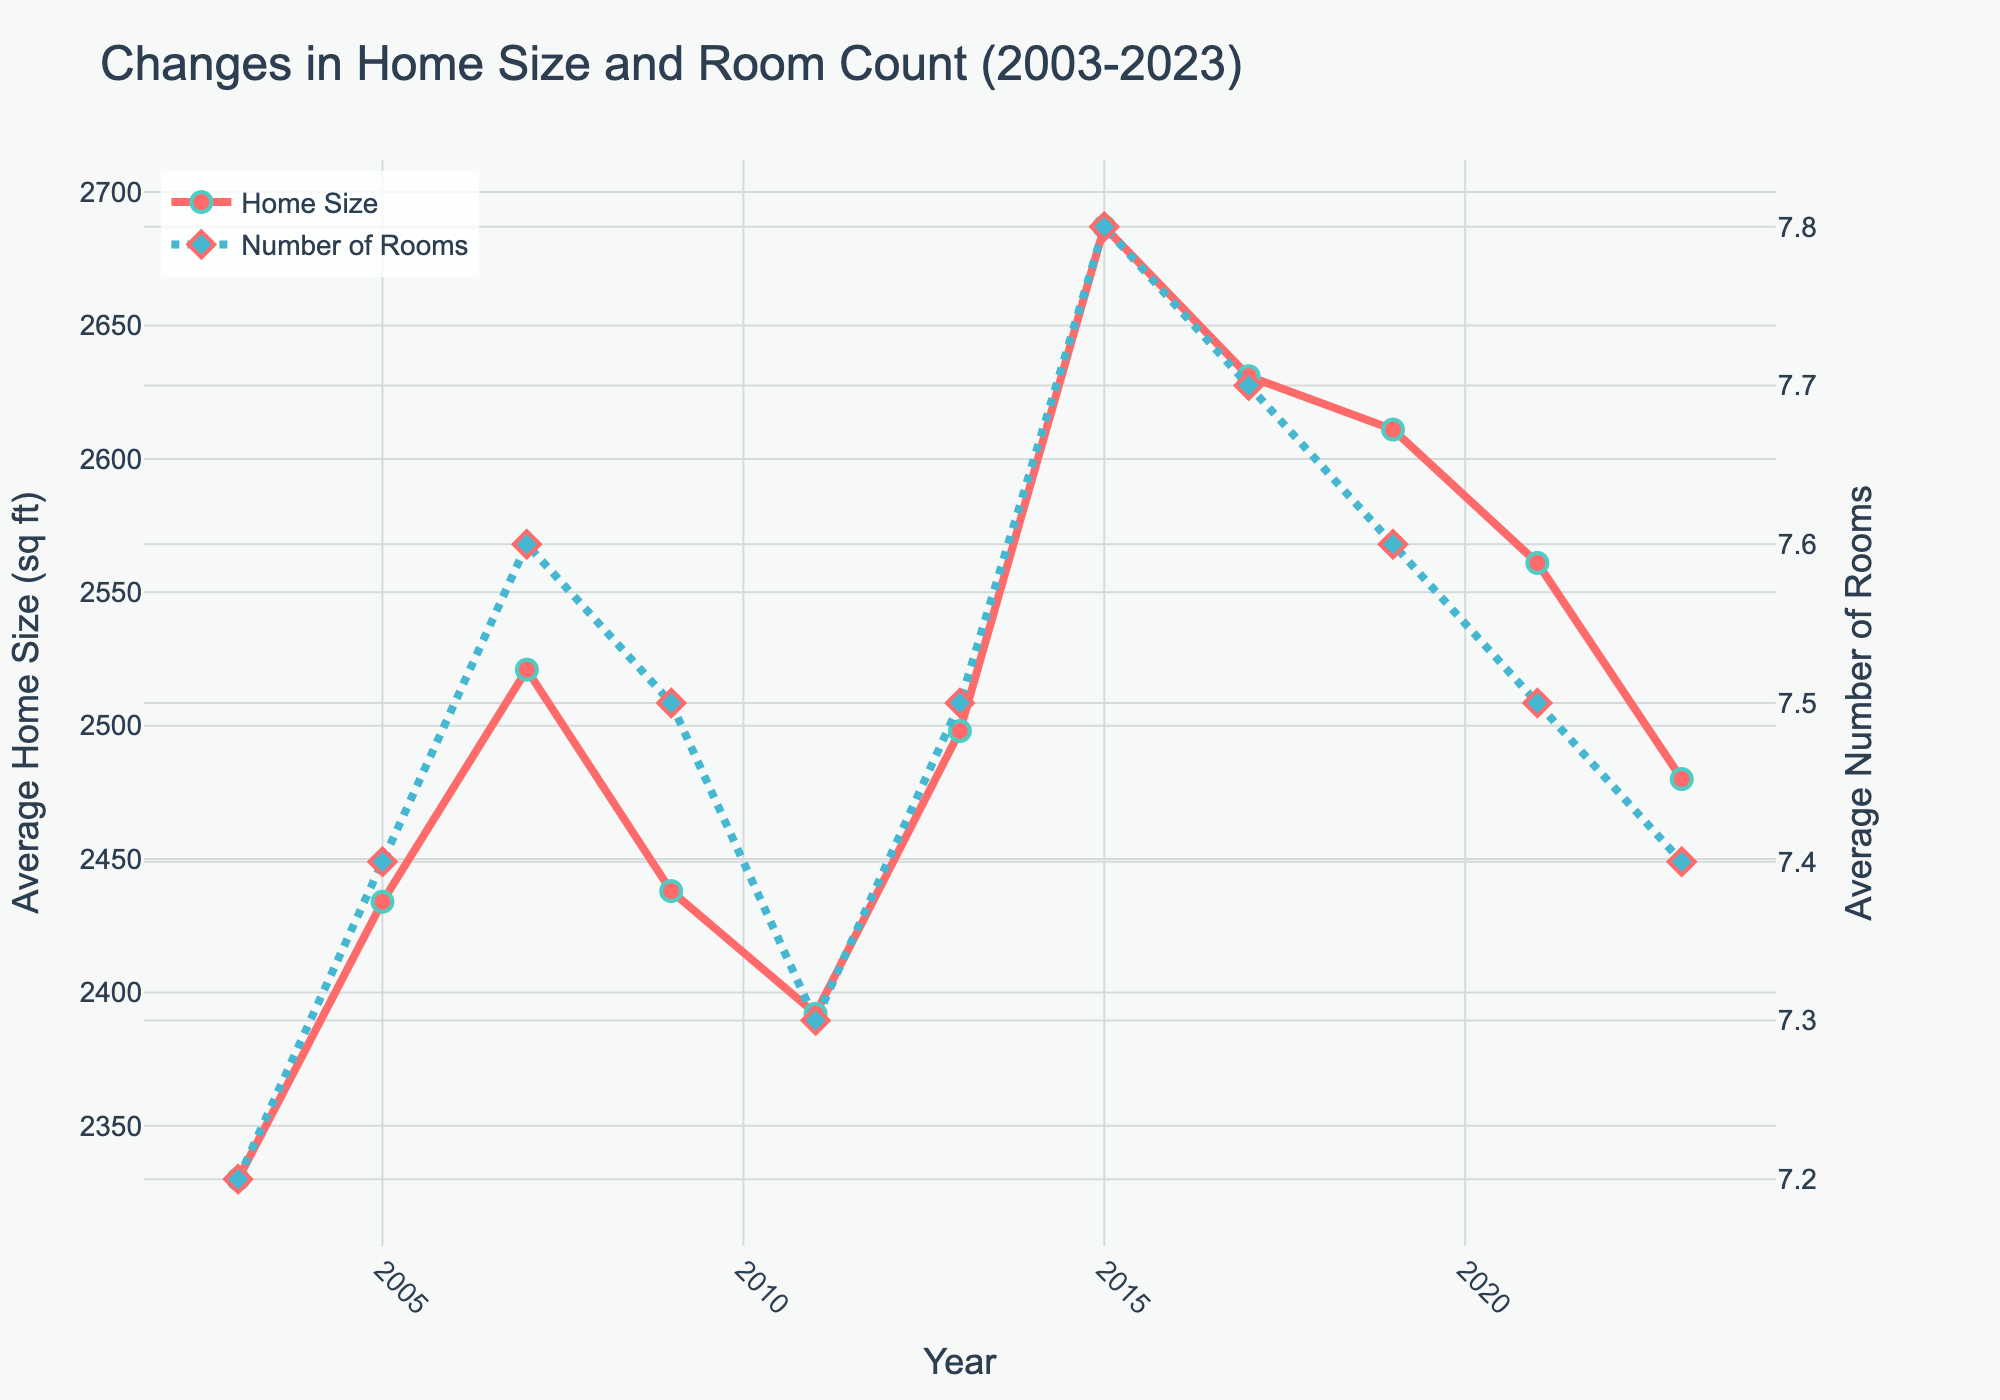What's the largest average home size recorded in the data? Locate the peak point on the "Home Size" line which is the highest on the y-axis. For these years, the highest average home size can be seen in 2015. Verification reveals that the average home size in 2015 is 2687 sq ft, which is the largest on the chart.
Answer: 2687 sq ft In which year was the average number of rooms the lowest? Look for the point on the "Number of Rooms" line that is the closest to the x-axis since fewer rooms mean a lower line. The lowest point appears to be in 2003 where the average number of rooms is 7.2.
Answer: 2003 Was there a year when the average number of rooms was higher than in the following year? Provide an example. Compare each pair of consecutive years on the "Number of Rooms" line to see where the number of rooms decreases. Between 2007 and 2009, the average number of rooms decreases from 7.6 to 7.5.
Answer: 2007 and 2009 What was the difference in home size between 2009 and 2011? Locate the points for 2009 and 2011 on the "Home Size" line. Subtract the size in 2011 from that in 2009: 2438 - 2392 = 46 sq ft.
Answer: 46 sq ft Between which years did the average home size increase the most? Identify the largest upward slope on the "Home Size" line. The steepest increase is from 2013 to 2015, where the size increased from 2498 to 2687 sq ft, a difference of 189 sq ft.
Answer: 2013 to 2015 How did the trend of the average number of rooms change from 2011 to 2015? The "Number of Rooms" line first slightly rises from 2011 (7.3) to 2013 (7.5), and then continues to rise to a higher peak at 2015 (7.8), showing an overall increase in this period.
Answer: Increased In the years when the average home size is larger than 2600 sq ft, what is the average number of rooms? Identify years where home size > 2600 sq ft: 2015 (2687) and 2017 (2631). The corresponding average number of rooms is 7.8 in 2015 and 7.7 in 2017. Calculate the average: (7.8 + 7.7) / 2 = 7.75.
Answer: 7.75 What's the overall trend in the average number of rooms from 2003 to 2023? Generally observe the pattern of the "Number of Rooms" line from 2003 to 2023. The line fluctuates but ends at about the same level as it started with a peak in 2015.
Answer: Relatively stable Which year had a higher average home size, 2005 or 2009? Compare the points for 2005 and 2009 on the "Home Size" line. In 2005, the size is 2434 sq ft, and in 2009, it is 2438 sq ft.
Answer: 2009 When did the average home size start to decline after reaching its peak? Identify the peak in 2015 and follow the "Home Size" line. The decline starts from 2015 (2687 sq ft) to 2017 (2631 sq ft).
Answer: 2015 